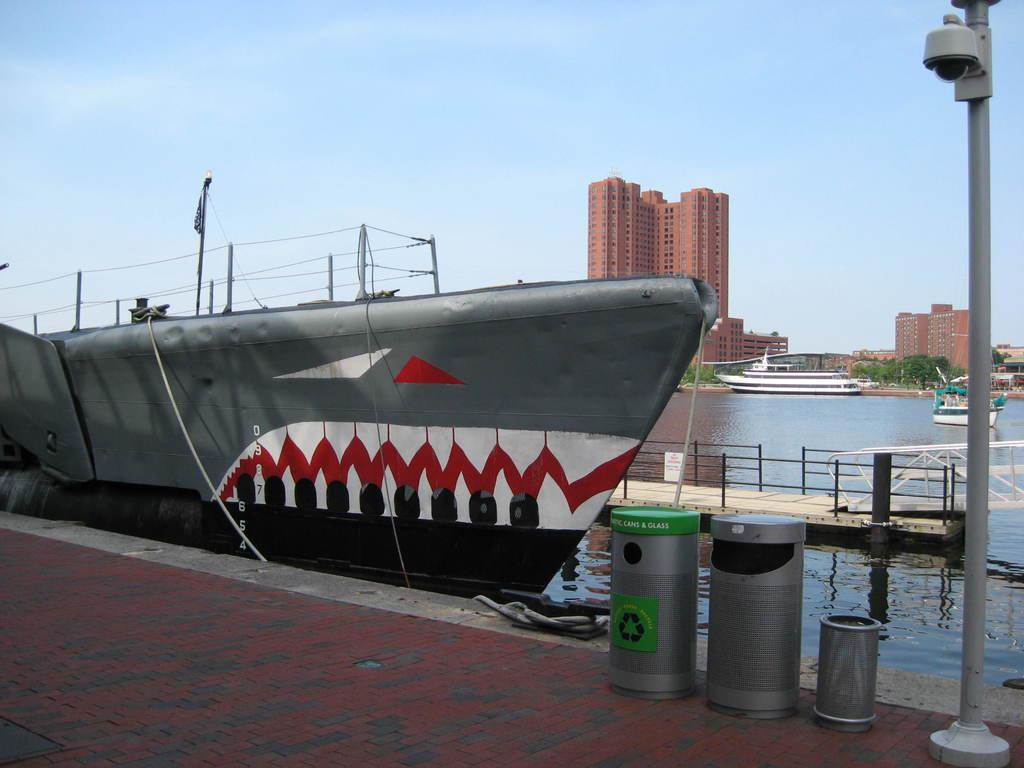<image>
Give a short and clear explanation of the subsequent image. A recycling bin has the words cans and glass on it. 